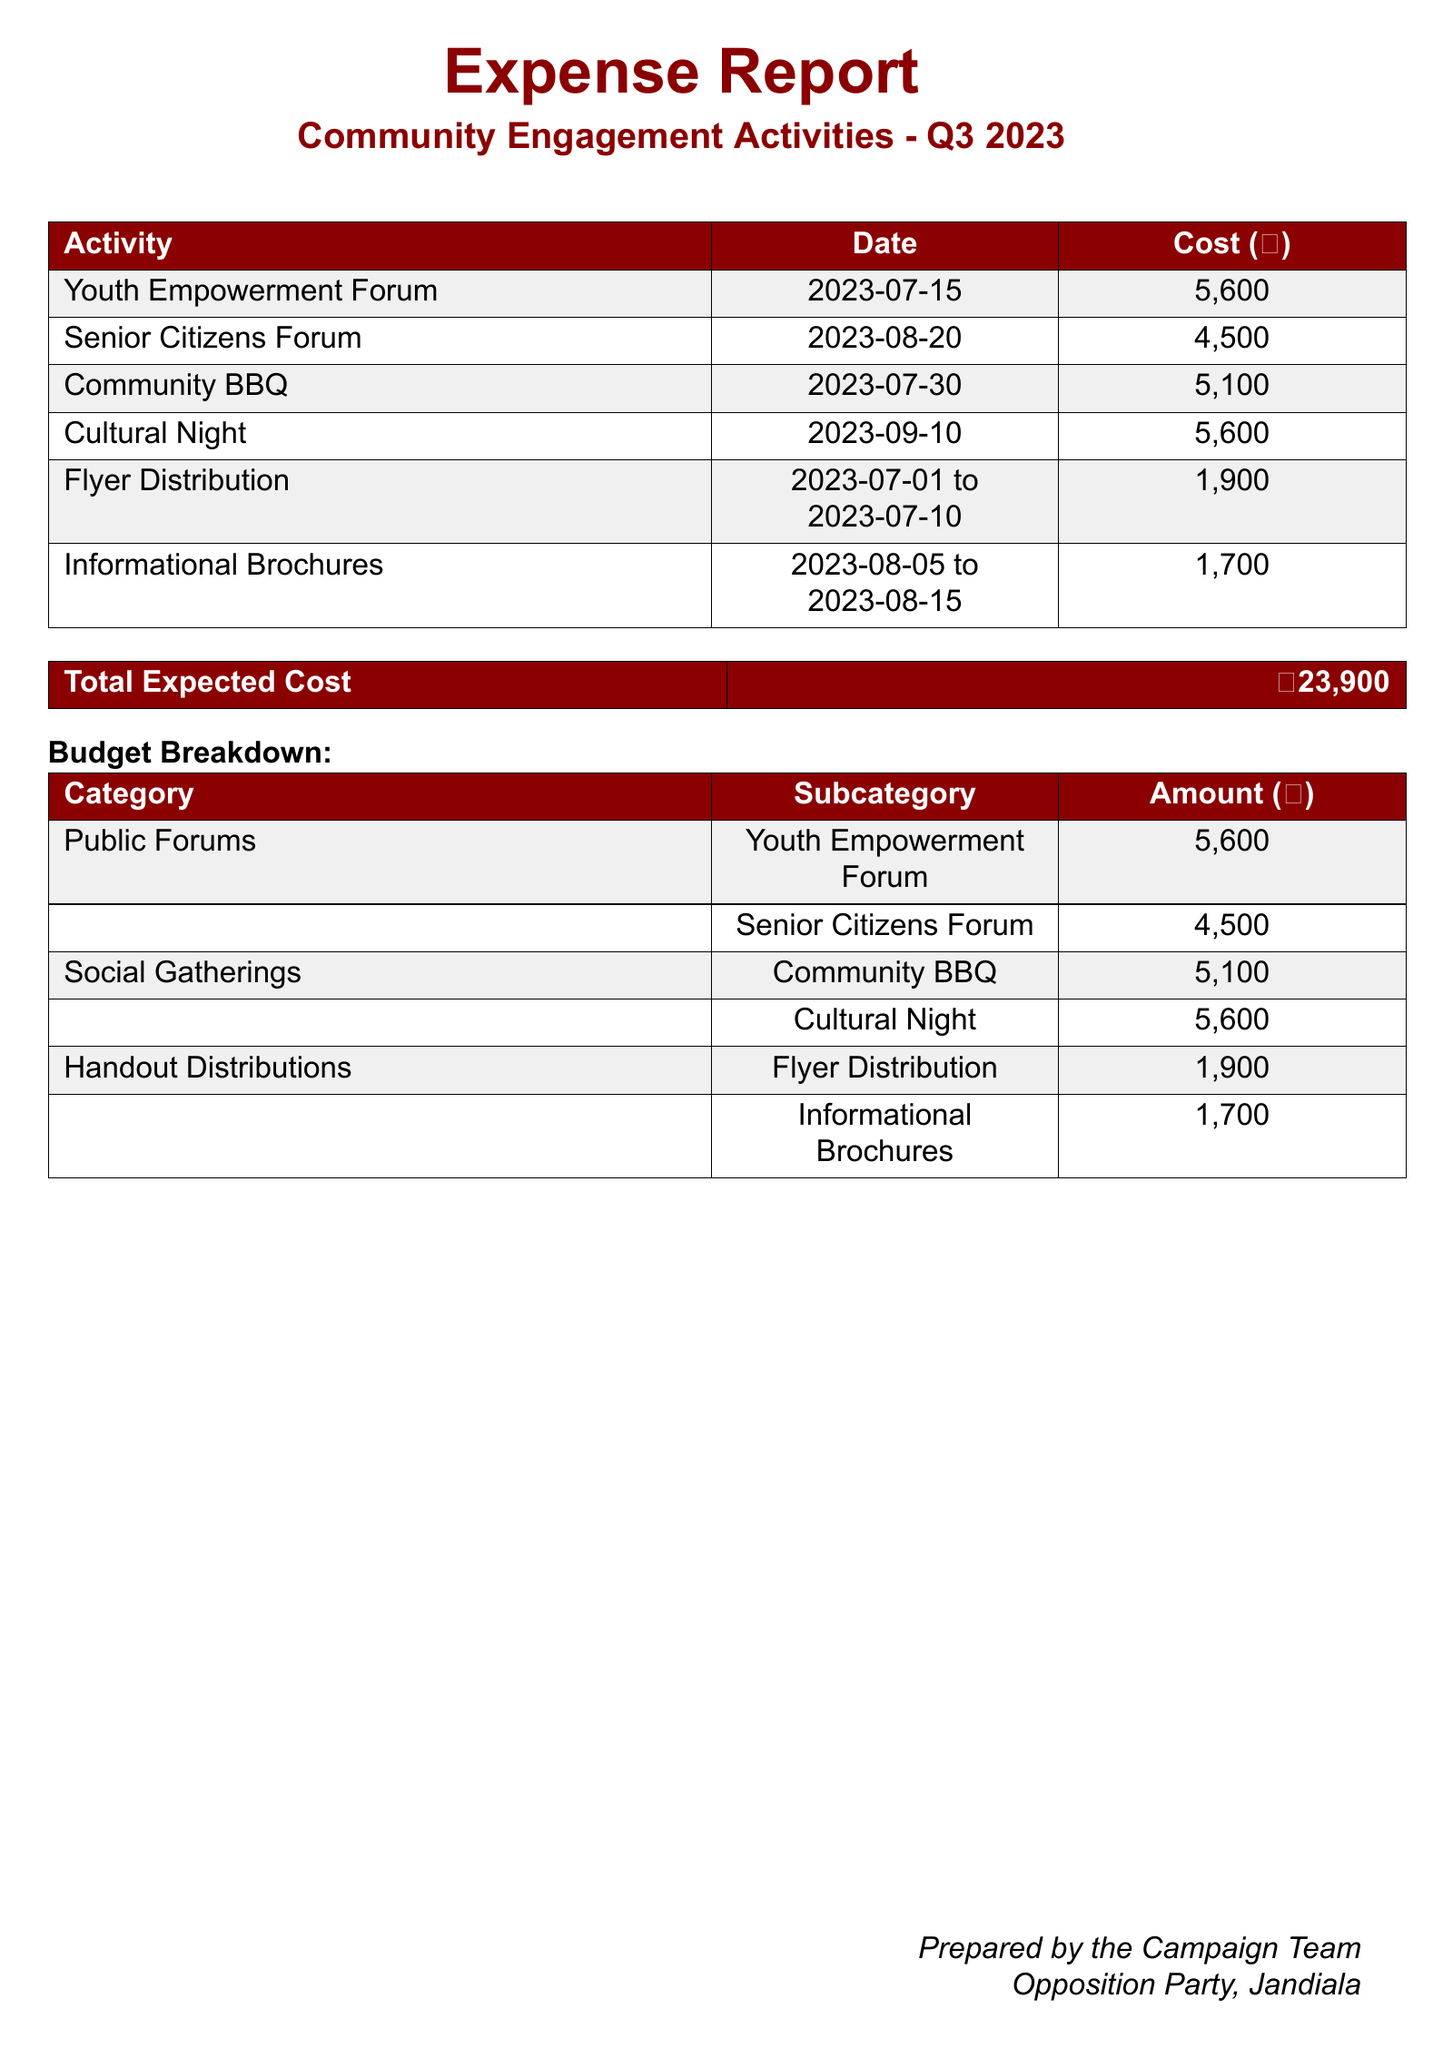What is the total expected cost for community engagement activities? The total expected cost is provided in the document, summarizing all the expenses listed.
Answer: ₹23,900 When was the Cultural Night event held? The date for the Cultural Night is specified in the document under community engagement activities.
Answer: 2023-09-10 How much was spent on the Youth Empowerment Forum? The cost for the Youth Empowerment Forum is explicitly listed in the expense report table.
Answer: ₹5,600 Which activity had the highest cost? By comparing all listed activities, we identify the one with the greatest expense.
Answer: Cultural Night What is the cost for flyer distribution? The cost associated with flyer distribution is outlined within the handout distributions section.
Answer: ₹1,900 How many social gatherings were organized? The social gatherings are detailed in the budget breakdown, requiring a count of the listed activities.
Answer: 2 What is the total cost for public forums? The total cost for public forums involves adding the costs for both forums listed.
Answer: ₹10,100 Which two categories are included in the budget breakdown? The budget breakdown lists multiple categories that are relevant to the activities.
Answer: Public Forums, Social Gatherings What type of document is this? The document clearly states its purpose and content in the title at the beginning of the report.
Answer: Expense Report 